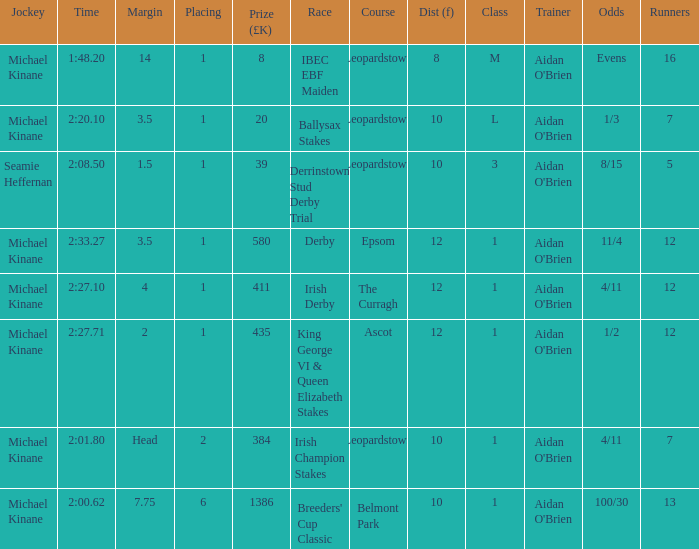Which Class has a Jockey of michael kinane on 2:27.71? 1.0. 